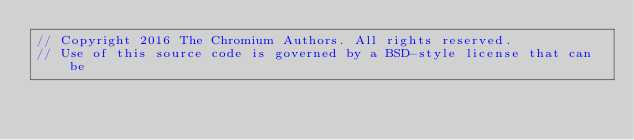Convert code to text. <code><loc_0><loc_0><loc_500><loc_500><_ObjectiveC_>// Copyright 2016 The Chromium Authors. All rights reserved.
// Use of this source code is governed by a BSD-style license that can be</code> 